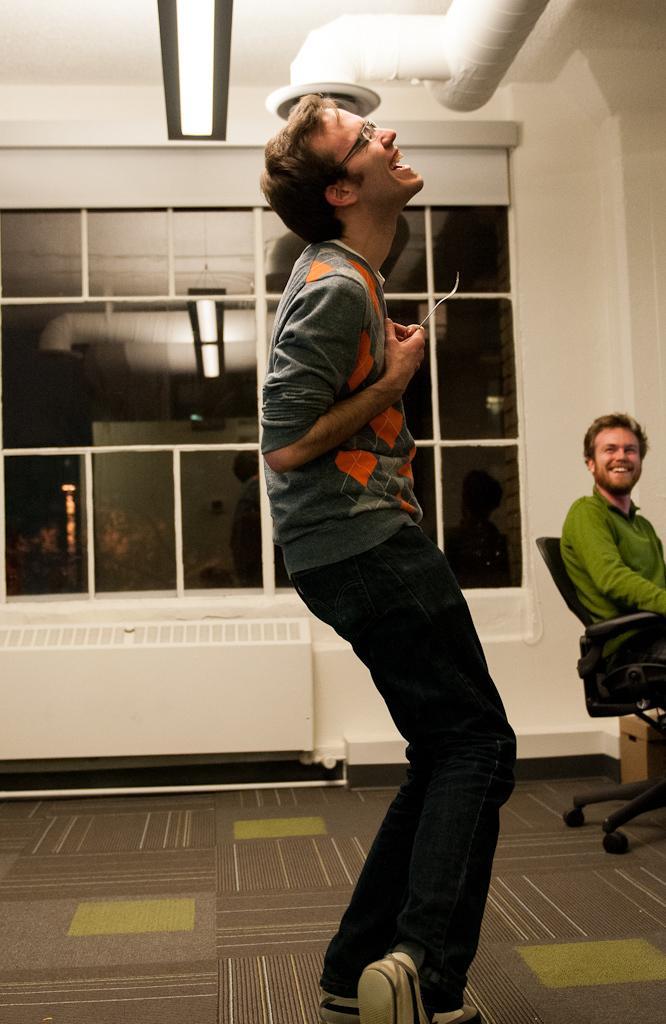How would you summarize this image in a sentence or two? This picture shows a man standing and laughing on the floor. And there is another man sitting in the chair and smiling. In the background there is a glass windows and a wall. 